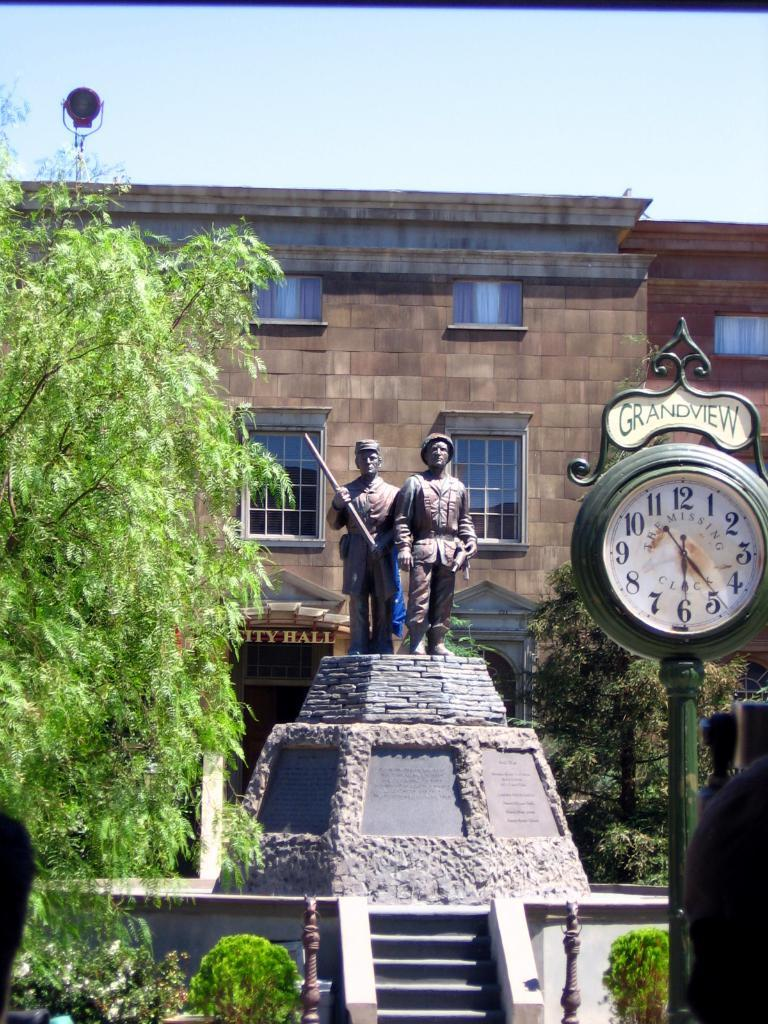<image>
Offer a succinct explanation of the picture presented. The Grandview clock in front of a raised statue of two soldiers which is in front of the City Hall building. 